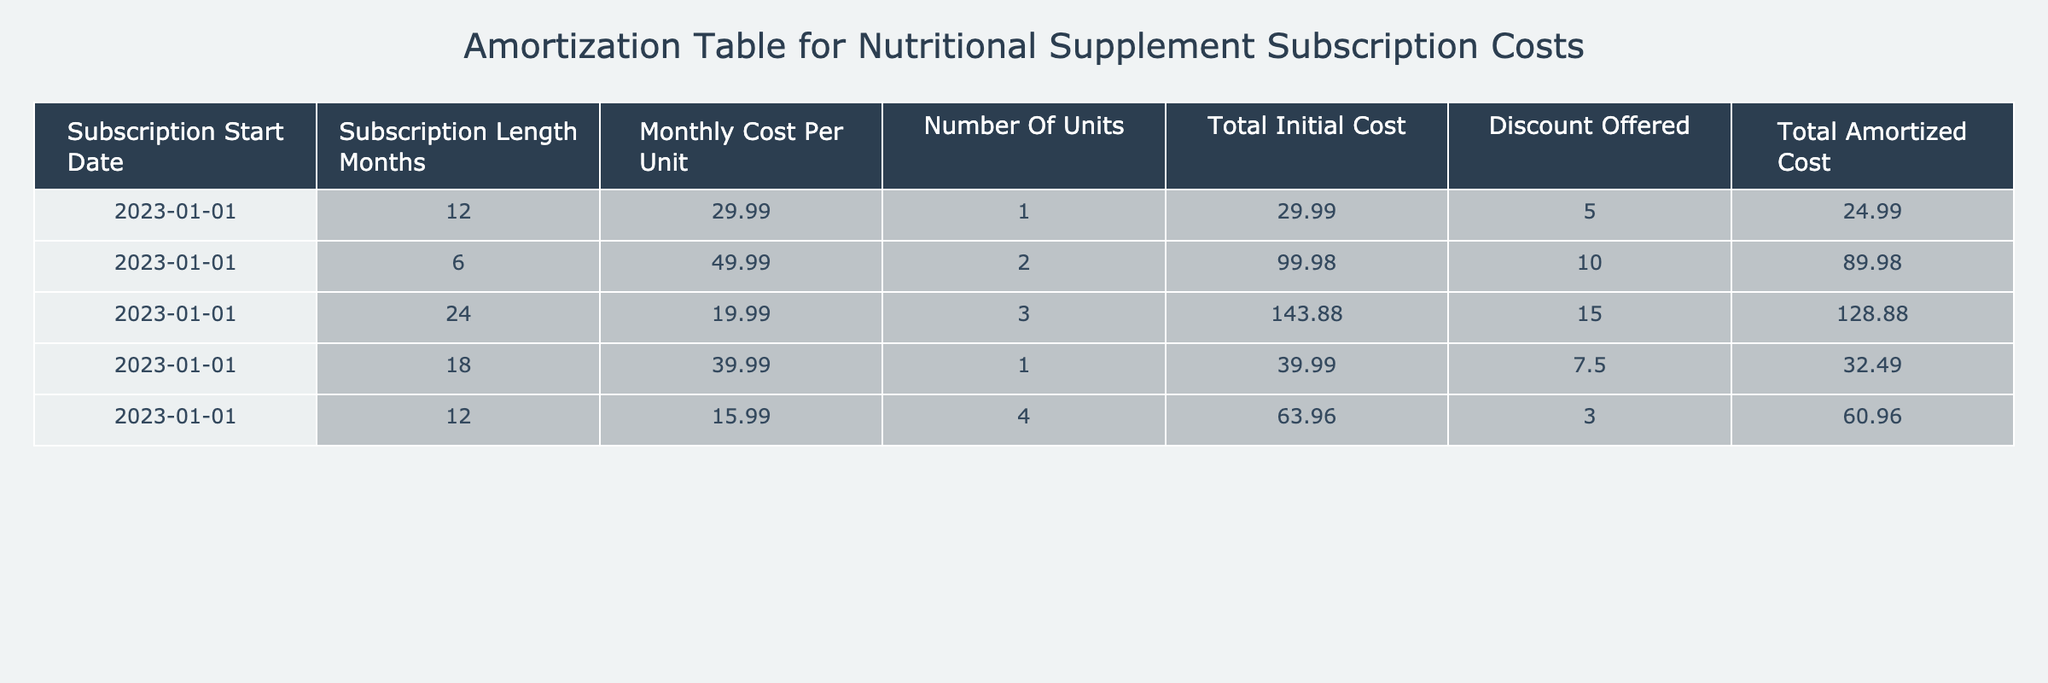What is the total initial cost for the subscription starting on January 1, 2023, for one unit at a monthly cost of 29.99? According to the table, the total initial cost for the subscription beginning on January 1, 2023, for one unit with a monthly cost of 29.99 is 29.99.
Answer: 29.99 How many months does the subscription last for the nutritional supplement with a total amortized cost of 89.98? The subscription with a total amortized cost of 89.98 lasts for 6 months since it is specified in the row corresponding to that cost.
Answer: 6 months What is the average monthly cost per unit across all subscriptions? To calculate the average monthly cost per unit, we sum the monthly costs (29.99 + 49.99 + 19.99 + 39.99 + 15.99 = 155.95) and divide by the number of subscriptions (5), which gives us 155.95 / 5 = 31.19.
Answer: 31.19 Is there a subscription that offers a discount greater than 10.00? By examining the discount offered column, we see that one of the subscriptions offers a discount of 10.00, but the subscription for three units at a monthly cost of 19.99 has a discount of 15.00, which is greater than 10.00. Therefore, the answer is yes.
Answer: Yes What is the total amortized cost for the subscription with the number of units equal to 4? Looking at the row for the subscription with 4 units, we see that the total amortized cost is 60.96.
Answer: 60.96 Which subscription has the lowest total amortized cost? By comparing the total amortized costs listed in the table (24.99, 89.98, 128.88, 32.49, 60.96), we can identify that the subscription with a total amortized cost of 24.99 is the lowest.
Answer: 24.99 If we sum the total initial costs of all subscriptions, what will the result be? Adding up all the total initial costs (29.99 + 99.98 + 143.88 + 39.99 + 63.96), we get 377.80.
Answer: 377.80 Is the total amortized cost more than the total initial cost for any of the subscriptions? By comparing the total initial costs and the total amortized costs for each subscription, we see that all total amortized costs (24.99, 89.98, 128.88, 32.49, 60.96) are less than their respective total initial costs, making the answer no.
Answer: No What is the difference between the highest and lowest monthly cost per unit? The highest monthly cost per unit is 49.99, and the lowest is 15.99. The difference is calculated as 49.99 - 15.99 = 34.00.
Answer: 34.00 